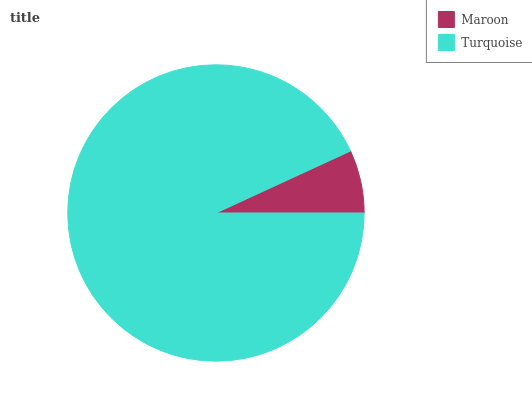Is Maroon the minimum?
Answer yes or no. Yes. Is Turquoise the maximum?
Answer yes or no. Yes. Is Turquoise the minimum?
Answer yes or no. No. Is Turquoise greater than Maroon?
Answer yes or no. Yes. Is Maroon less than Turquoise?
Answer yes or no. Yes. Is Maroon greater than Turquoise?
Answer yes or no. No. Is Turquoise less than Maroon?
Answer yes or no. No. Is Turquoise the high median?
Answer yes or no. Yes. Is Maroon the low median?
Answer yes or no. Yes. Is Maroon the high median?
Answer yes or no. No. Is Turquoise the low median?
Answer yes or no. No. 